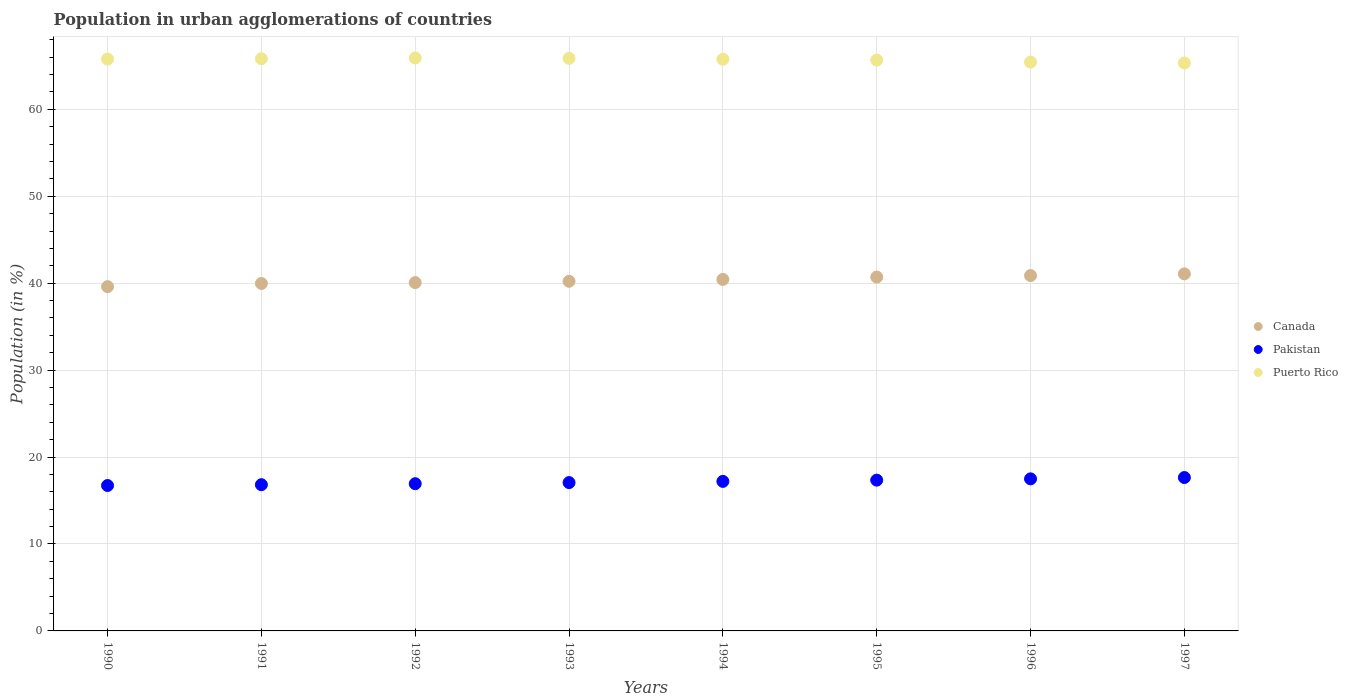What is the percentage of population in urban agglomerations in Puerto Rico in 1993?
Your answer should be very brief. 65.87. Across all years, what is the maximum percentage of population in urban agglomerations in Canada?
Your response must be concise. 41.07. Across all years, what is the minimum percentage of population in urban agglomerations in Puerto Rico?
Your response must be concise. 65.33. What is the total percentage of population in urban agglomerations in Puerto Rico in the graph?
Give a very brief answer. 525.58. What is the difference between the percentage of population in urban agglomerations in Puerto Rico in 1995 and that in 1997?
Make the answer very short. 0.33. What is the difference between the percentage of population in urban agglomerations in Puerto Rico in 1992 and the percentage of population in urban agglomerations in Pakistan in 1997?
Make the answer very short. 48.27. What is the average percentage of population in urban agglomerations in Puerto Rico per year?
Provide a succinct answer. 65.7. In the year 1990, what is the difference between the percentage of population in urban agglomerations in Canada and percentage of population in urban agglomerations in Puerto Rico?
Offer a very short reply. -26.18. In how many years, is the percentage of population in urban agglomerations in Puerto Rico greater than 50 %?
Ensure brevity in your answer.  8. What is the ratio of the percentage of population in urban agglomerations in Canada in 1990 to that in 1997?
Give a very brief answer. 0.96. Is the percentage of population in urban agglomerations in Canada in 1992 less than that in 1993?
Offer a terse response. Yes. Is the difference between the percentage of population in urban agglomerations in Canada in 1991 and 1997 greater than the difference between the percentage of population in urban agglomerations in Puerto Rico in 1991 and 1997?
Keep it short and to the point. No. What is the difference between the highest and the second highest percentage of population in urban agglomerations in Puerto Rico?
Your response must be concise. 0.05. What is the difference between the highest and the lowest percentage of population in urban agglomerations in Pakistan?
Your answer should be compact. 0.92. Is it the case that in every year, the sum of the percentage of population in urban agglomerations in Pakistan and percentage of population in urban agglomerations in Puerto Rico  is greater than the percentage of population in urban agglomerations in Canada?
Your answer should be very brief. Yes. Is the percentage of population in urban agglomerations in Pakistan strictly less than the percentage of population in urban agglomerations in Puerto Rico over the years?
Your answer should be very brief. Yes. How many years are there in the graph?
Make the answer very short. 8. What is the difference between two consecutive major ticks on the Y-axis?
Your response must be concise. 10. Are the values on the major ticks of Y-axis written in scientific E-notation?
Keep it short and to the point. No. Does the graph contain any zero values?
Your response must be concise. No. Does the graph contain grids?
Your answer should be compact. Yes. How many legend labels are there?
Your response must be concise. 3. What is the title of the graph?
Your answer should be very brief. Population in urban agglomerations of countries. What is the Population (in %) in Canada in 1990?
Your answer should be compact. 39.6. What is the Population (in %) of Pakistan in 1990?
Provide a short and direct response. 16.73. What is the Population (in %) in Puerto Rico in 1990?
Offer a terse response. 65.78. What is the Population (in %) in Canada in 1991?
Your response must be concise. 39.97. What is the Population (in %) in Pakistan in 1991?
Your answer should be compact. 16.82. What is the Population (in %) of Puerto Rico in 1991?
Provide a succinct answer. 65.83. What is the Population (in %) in Canada in 1992?
Your answer should be very brief. 40.07. What is the Population (in %) in Pakistan in 1992?
Give a very brief answer. 16.94. What is the Population (in %) of Puerto Rico in 1992?
Provide a short and direct response. 65.91. What is the Population (in %) of Canada in 1993?
Your answer should be very brief. 40.22. What is the Population (in %) in Pakistan in 1993?
Make the answer very short. 17.06. What is the Population (in %) of Puerto Rico in 1993?
Offer a very short reply. 65.87. What is the Population (in %) in Canada in 1994?
Your answer should be compact. 40.44. What is the Population (in %) in Pakistan in 1994?
Offer a terse response. 17.2. What is the Population (in %) in Puerto Rico in 1994?
Your response must be concise. 65.76. What is the Population (in %) of Canada in 1995?
Offer a terse response. 40.7. What is the Population (in %) in Pakistan in 1995?
Give a very brief answer. 17.35. What is the Population (in %) of Puerto Rico in 1995?
Your response must be concise. 65.66. What is the Population (in %) of Canada in 1996?
Your answer should be very brief. 40.88. What is the Population (in %) in Pakistan in 1996?
Provide a succinct answer. 17.49. What is the Population (in %) of Puerto Rico in 1996?
Ensure brevity in your answer.  65.44. What is the Population (in %) in Canada in 1997?
Provide a short and direct response. 41.07. What is the Population (in %) in Pakistan in 1997?
Offer a very short reply. 17.64. What is the Population (in %) in Puerto Rico in 1997?
Provide a short and direct response. 65.33. Across all years, what is the maximum Population (in %) of Canada?
Provide a succinct answer. 41.07. Across all years, what is the maximum Population (in %) in Pakistan?
Offer a very short reply. 17.64. Across all years, what is the maximum Population (in %) of Puerto Rico?
Make the answer very short. 65.91. Across all years, what is the minimum Population (in %) in Canada?
Make the answer very short. 39.6. Across all years, what is the minimum Population (in %) of Pakistan?
Make the answer very short. 16.73. Across all years, what is the minimum Population (in %) in Puerto Rico?
Keep it short and to the point. 65.33. What is the total Population (in %) of Canada in the graph?
Ensure brevity in your answer.  322.95. What is the total Population (in %) in Pakistan in the graph?
Keep it short and to the point. 137.23. What is the total Population (in %) in Puerto Rico in the graph?
Provide a short and direct response. 525.58. What is the difference between the Population (in %) in Canada in 1990 and that in 1991?
Provide a short and direct response. -0.37. What is the difference between the Population (in %) of Pakistan in 1990 and that in 1991?
Provide a succinct answer. -0.09. What is the difference between the Population (in %) in Puerto Rico in 1990 and that in 1991?
Offer a very short reply. -0.04. What is the difference between the Population (in %) of Canada in 1990 and that in 1992?
Your response must be concise. -0.47. What is the difference between the Population (in %) of Pakistan in 1990 and that in 1992?
Provide a succinct answer. -0.21. What is the difference between the Population (in %) in Puerto Rico in 1990 and that in 1992?
Ensure brevity in your answer.  -0.13. What is the difference between the Population (in %) in Canada in 1990 and that in 1993?
Provide a short and direct response. -0.62. What is the difference between the Population (in %) in Pakistan in 1990 and that in 1993?
Your response must be concise. -0.34. What is the difference between the Population (in %) in Puerto Rico in 1990 and that in 1993?
Keep it short and to the point. -0.08. What is the difference between the Population (in %) in Canada in 1990 and that in 1994?
Offer a very short reply. -0.83. What is the difference between the Population (in %) of Pakistan in 1990 and that in 1994?
Your response must be concise. -0.47. What is the difference between the Population (in %) in Puerto Rico in 1990 and that in 1994?
Offer a very short reply. 0.02. What is the difference between the Population (in %) of Canada in 1990 and that in 1995?
Your answer should be compact. -1.1. What is the difference between the Population (in %) in Pakistan in 1990 and that in 1995?
Your answer should be compact. -0.62. What is the difference between the Population (in %) of Puerto Rico in 1990 and that in 1995?
Your answer should be compact. 0.12. What is the difference between the Population (in %) of Canada in 1990 and that in 1996?
Keep it short and to the point. -1.28. What is the difference between the Population (in %) of Pakistan in 1990 and that in 1996?
Make the answer very short. -0.77. What is the difference between the Population (in %) in Puerto Rico in 1990 and that in 1996?
Provide a short and direct response. 0.35. What is the difference between the Population (in %) in Canada in 1990 and that in 1997?
Your response must be concise. -1.47. What is the difference between the Population (in %) of Pakistan in 1990 and that in 1997?
Your answer should be very brief. -0.92. What is the difference between the Population (in %) of Puerto Rico in 1990 and that in 1997?
Provide a short and direct response. 0.45. What is the difference between the Population (in %) of Canada in 1991 and that in 1992?
Your answer should be very brief. -0.1. What is the difference between the Population (in %) in Pakistan in 1991 and that in 1992?
Your response must be concise. -0.11. What is the difference between the Population (in %) in Puerto Rico in 1991 and that in 1992?
Offer a terse response. -0.08. What is the difference between the Population (in %) of Canada in 1991 and that in 1993?
Provide a succinct answer. -0.26. What is the difference between the Population (in %) of Pakistan in 1991 and that in 1993?
Your answer should be very brief. -0.24. What is the difference between the Population (in %) in Puerto Rico in 1991 and that in 1993?
Offer a very short reply. -0.04. What is the difference between the Population (in %) in Canada in 1991 and that in 1994?
Make the answer very short. -0.47. What is the difference between the Population (in %) in Pakistan in 1991 and that in 1994?
Give a very brief answer. -0.38. What is the difference between the Population (in %) in Puerto Rico in 1991 and that in 1994?
Offer a very short reply. 0.06. What is the difference between the Population (in %) in Canada in 1991 and that in 1995?
Your response must be concise. -0.74. What is the difference between the Population (in %) in Pakistan in 1991 and that in 1995?
Provide a short and direct response. -0.52. What is the difference between the Population (in %) of Puerto Rico in 1991 and that in 1995?
Give a very brief answer. 0.16. What is the difference between the Population (in %) in Canada in 1991 and that in 1996?
Offer a terse response. -0.91. What is the difference between the Population (in %) of Pakistan in 1991 and that in 1996?
Provide a short and direct response. -0.67. What is the difference between the Population (in %) of Puerto Rico in 1991 and that in 1996?
Your response must be concise. 0.39. What is the difference between the Population (in %) in Canada in 1991 and that in 1997?
Make the answer very short. -1.11. What is the difference between the Population (in %) in Pakistan in 1991 and that in 1997?
Ensure brevity in your answer.  -0.82. What is the difference between the Population (in %) of Puerto Rico in 1991 and that in 1997?
Offer a terse response. 0.49. What is the difference between the Population (in %) of Canada in 1992 and that in 1993?
Your answer should be very brief. -0.15. What is the difference between the Population (in %) in Pakistan in 1992 and that in 1993?
Offer a terse response. -0.13. What is the difference between the Population (in %) of Puerto Rico in 1992 and that in 1993?
Ensure brevity in your answer.  0.05. What is the difference between the Population (in %) of Canada in 1992 and that in 1994?
Ensure brevity in your answer.  -0.37. What is the difference between the Population (in %) in Pakistan in 1992 and that in 1994?
Your response must be concise. -0.27. What is the difference between the Population (in %) of Puerto Rico in 1992 and that in 1994?
Ensure brevity in your answer.  0.15. What is the difference between the Population (in %) in Canada in 1992 and that in 1995?
Provide a succinct answer. -0.64. What is the difference between the Population (in %) of Pakistan in 1992 and that in 1995?
Give a very brief answer. -0.41. What is the difference between the Population (in %) of Puerto Rico in 1992 and that in 1995?
Your answer should be very brief. 0.25. What is the difference between the Population (in %) in Canada in 1992 and that in 1996?
Give a very brief answer. -0.81. What is the difference between the Population (in %) in Pakistan in 1992 and that in 1996?
Keep it short and to the point. -0.56. What is the difference between the Population (in %) of Puerto Rico in 1992 and that in 1996?
Make the answer very short. 0.48. What is the difference between the Population (in %) of Canada in 1992 and that in 1997?
Your answer should be very brief. -1.01. What is the difference between the Population (in %) in Pakistan in 1992 and that in 1997?
Your response must be concise. -0.71. What is the difference between the Population (in %) of Puerto Rico in 1992 and that in 1997?
Make the answer very short. 0.58. What is the difference between the Population (in %) of Canada in 1993 and that in 1994?
Give a very brief answer. -0.21. What is the difference between the Population (in %) of Pakistan in 1993 and that in 1994?
Your answer should be very brief. -0.14. What is the difference between the Population (in %) in Puerto Rico in 1993 and that in 1994?
Ensure brevity in your answer.  0.1. What is the difference between the Population (in %) of Canada in 1993 and that in 1995?
Give a very brief answer. -0.48. What is the difference between the Population (in %) of Pakistan in 1993 and that in 1995?
Your answer should be very brief. -0.28. What is the difference between the Population (in %) of Puerto Rico in 1993 and that in 1995?
Ensure brevity in your answer.  0.2. What is the difference between the Population (in %) of Canada in 1993 and that in 1996?
Give a very brief answer. -0.65. What is the difference between the Population (in %) in Pakistan in 1993 and that in 1996?
Make the answer very short. -0.43. What is the difference between the Population (in %) in Puerto Rico in 1993 and that in 1996?
Offer a terse response. 0.43. What is the difference between the Population (in %) of Canada in 1993 and that in 1997?
Your response must be concise. -0.85. What is the difference between the Population (in %) of Pakistan in 1993 and that in 1997?
Offer a very short reply. -0.58. What is the difference between the Population (in %) in Puerto Rico in 1993 and that in 1997?
Your answer should be compact. 0.53. What is the difference between the Population (in %) of Canada in 1994 and that in 1995?
Give a very brief answer. -0.27. What is the difference between the Population (in %) of Pakistan in 1994 and that in 1995?
Offer a terse response. -0.14. What is the difference between the Population (in %) of Puerto Rico in 1994 and that in 1995?
Offer a terse response. 0.1. What is the difference between the Population (in %) in Canada in 1994 and that in 1996?
Make the answer very short. -0.44. What is the difference between the Population (in %) in Pakistan in 1994 and that in 1996?
Give a very brief answer. -0.29. What is the difference between the Population (in %) in Puerto Rico in 1994 and that in 1996?
Provide a short and direct response. 0.33. What is the difference between the Population (in %) in Canada in 1994 and that in 1997?
Your answer should be compact. -0.64. What is the difference between the Population (in %) of Pakistan in 1994 and that in 1997?
Offer a terse response. -0.44. What is the difference between the Population (in %) in Puerto Rico in 1994 and that in 1997?
Provide a succinct answer. 0.43. What is the difference between the Population (in %) in Canada in 1995 and that in 1996?
Your response must be concise. -0.17. What is the difference between the Population (in %) in Pakistan in 1995 and that in 1996?
Your answer should be very brief. -0.15. What is the difference between the Population (in %) in Puerto Rico in 1995 and that in 1996?
Offer a very short reply. 0.23. What is the difference between the Population (in %) in Canada in 1995 and that in 1997?
Offer a terse response. -0.37. What is the difference between the Population (in %) of Pakistan in 1995 and that in 1997?
Make the answer very short. -0.3. What is the difference between the Population (in %) in Puerto Rico in 1995 and that in 1997?
Offer a very short reply. 0.33. What is the difference between the Population (in %) in Canada in 1996 and that in 1997?
Offer a very short reply. -0.2. What is the difference between the Population (in %) in Pakistan in 1996 and that in 1997?
Offer a terse response. -0.15. What is the difference between the Population (in %) of Puerto Rico in 1996 and that in 1997?
Your answer should be compact. 0.1. What is the difference between the Population (in %) of Canada in 1990 and the Population (in %) of Pakistan in 1991?
Your answer should be very brief. 22.78. What is the difference between the Population (in %) in Canada in 1990 and the Population (in %) in Puerto Rico in 1991?
Your response must be concise. -26.22. What is the difference between the Population (in %) in Pakistan in 1990 and the Population (in %) in Puerto Rico in 1991?
Your answer should be compact. -49.1. What is the difference between the Population (in %) of Canada in 1990 and the Population (in %) of Pakistan in 1992?
Your answer should be compact. 22.67. What is the difference between the Population (in %) of Canada in 1990 and the Population (in %) of Puerto Rico in 1992?
Offer a very short reply. -26.31. What is the difference between the Population (in %) of Pakistan in 1990 and the Population (in %) of Puerto Rico in 1992?
Give a very brief answer. -49.18. What is the difference between the Population (in %) of Canada in 1990 and the Population (in %) of Pakistan in 1993?
Make the answer very short. 22.54. What is the difference between the Population (in %) of Canada in 1990 and the Population (in %) of Puerto Rico in 1993?
Keep it short and to the point. -26.26. What is the difference between the Population (in %) of Pakistan in 1990 and the Population (in %) of Puerto Rico in 1993?
Keep it short and to the point. -49.14. What is the difference between the Population (in %) of Canada in 1990 and the Population (in %) of Pakistan in 1994?
Make the answer very short. 22.4. What is the difference between the Population (in %) in Canada in 1990 and the Population (in %) in Puerto Rico in 1994?
Keep it short and to the point. -26.16. What is the difference between the Population (in %) of Pakistan in 1990 and the Population (in %) of Puerto Rico in 1994?
Your response must be concise. -49.04. What is the difference between the Population (in %) of Canada in 1990 and the Population (in %) of Pakistan in 1995?
Ensure brevity in your answer.  22.26. What is the difference between the Population (in %) in Canada in 1990 and the Population (in %) in Puerto Rico in 1995?
Give a very brief answer. -26.06. What is the difference between the Population (in %) in Pakistan in 1990 and the Population (in %) in Puerto Rico in 1995?
Your response must be concise. -48.94. What is the difference between the Population (in %) of Canada in 1990 and the Population (in %) of Pakistan in 1996?
Your answer should be compact. 22.11. What is the difference between the Population (in %) in Canada in 1990 and the Population (in %) in Puerto Rico in 1996?
Your answer should be compact. -25.83. What is the difference between the Population (in %) of Pakistan in 1990 and the Population (in %) of Puerto Rico in 1996?
Your answer should be compact. -48.71. What is the difference between the Population (in %) in Canada in 1990 and the Population (in %) in Pakistan in 1997?
Offer a terse response. 21.96. What is the difference between the Population (in %) in Canada in 1990 and the Population (in %) in Puerto Rico in 1997?
Provide a succinct answer. -25.73. What is the difference between the Population (in %) of Pakistan in 1990 and the Population (in %) of Puerto Rico in 1997?
Your answer should be very brief. -48.61. What is the difference between the Population (in %) in Canada in 1991 and the Population (in %) in Pakistan in 1992?
Keep it short and to the point. 23.03. What is the difference between the Population (in %) of Canada in 1991 and the Population (in %) of Puerto Rico in 1992?
Make the answer very short. -25.94. What is the difference between the Population (in %) of Pakistan in 1991 and the Population (in %) of Puerto Rico in 1992?
Your answer should be compact. -49.09. What is the difference between the Population (in %) in Canada in 1991 and the Population (in %) in Pakistan in 1993?
Your response must be concise. 22.91. What is the difference between the Population (in %) in Canada in 1991 and the Population (in %) in Puerto Rico in 1993?
Your answer should be very brief. -25.9. What is the difference between the Population (in %) in Pakistan in 1991 and the Population (in %) in Puerto Rico in 1993?
Offer a very short reply. -49.04. What is the difference between the Population (in %) of Canada in 1991 and the Population (in %) of Pakistan in 1994?
Provide a succinct answer. 22.77. What is the difference between the Population (in %) in Canada in 1991 and the Population (in %) in Puerto Rico in 1994?
Provide a short and direct response. -25.79. What is the difference between the Population (in %) of Pakistan in 1991 and the Population (in %) of Puerto Rico in 1994?
Your answer should be compact. -48.94. What is the difference between the Population (in %) of Canada in 1991 and the Population (in %) of Pakistan in 1995?
Keep it short and to the point. 22.62. What is the difference between the Population (in %) of Canada in 1991 and the Population (in %) of Puerto Rico in 1995?
Provide a short and direct response. -25.7. What is the difference between the Population (in %) in Pakistan in 1991 and the Population (in %) in Puerto Rico in 1995?
Keep it short and to the point. -48.84. What is the difference between the Population (in %) of Canada in 1991 and the Population (in %) of Pakistan in 1996?
Provide a short and direct response. 22.48. What is the difference between the Population (in %) in Canada in 1991 and the Population (in %) in Puerto Rico in 1996?
Give a very brief answer. -25.47. What is the difference between the Population (in %) of Pakistan in 1991 and the Population (in %) of Puerto Rico in 1996?
Provide a short and direct response. -48.62. What is the difference between the Population (in %) of Canada in 1991 and the Population (in %) of Pakistan in 1997?
Your answer should be very brief. 22.32. What is the difference between the Population (in %) in Canada in 1991 and the Population (in %) in Puerto Rico in 1997?
Offer a terse response. -25.37. What is the difference between the Population (in %) in Pakistan in 1991 and the Population (in %) in Puerto Rico in 1997?
Provide a short and direct response. -48.51. What is the difference between the Population (in %) in Canada in 1992 and the Population (in %) in Pakistan in 1993?
Provide a short and direct response. 23.01. What is the difference between the Population (in %) of Canada in 1992 and the Population (in %) of Puerto Rico in 1993?
Offer a terse response. -25.8. What is the difference between the Population (in %) in Pakistan in 1992 and the Population (in %) in Puerto Rico in 1993?
Keep it short and to the point. -48.93. What is the difference between the Population (in %) in Canada in 1992 and the Population (in %) in Pakistan in 1994?
Make the answer very short. 22.87. What is the difference between the Population (in %) of Canada in 1992 and the Population (in %) of Puerto Rico in 1994?
Make the answer very short. -25.69. What is the difference between the Population (in %) in Pakistan in 1992 and the Population (in %) in Puerto Rico in 1994?
Give a very brief answer. -48.83. What is the difference between the Population (in %) of Canada in 1992 and the Population (in %) of Pakistan in 1995?
Give a very brief answer. 22.72. What is the difference between the Population (in %) of Canada in 1992 and the Population (in %) of Puerto Rico in 1995?
Make the answer very short. -25.6. What is the difference between the Population (in %) of Pakistan in 1992 and the Population (in %) of Puerto Rico in 1995?
Keep it short and to the point. -48.73. What is the difference between the Population (in %) in Canada in 1992 and the Population (in %) in Pakistan in 1996?
Give a very brief answer. 22.58. What is the difference between the Population (in %) of Canada in 1992 and the Population (in %) of Puerto Rico in 1996?
Provide a succinct answer. -25.37. What is the difference between the Population (in %) in Pakistan in 1992 and the Population (in %) in Puerto Rico in 1996?
Make the answer very short. -48.5. What is the difference between the Population (in %) of Canada in 1992 and the Population (in %) of Pakistan in 1997?
Your response must be concise. 22.42. What is the difference between the Population (in %) in Canada in 1992 and the Population (in %) in Puerto Rico in 1997?
Provide a short and direct response. -25.26. What is the difference between the Population (in %) of Pakistan in 1992 and the Population (in %) of Puerto Rico in 1997?
Ensure brevity in your answer.  -48.4. What is the difference between the Population (in %) of Canada in 1993 and the Population (in %) of Pakistan in 1994?
Your answer should be compact. 23.02. What is the difference between the Population (in %) in Canada in 1993 and the Population (in %) in Puerto Rico in 1994?
Keep it short and to the point. -25.54. What is the difference between the Population (in %) of Pakistan in 1993 and the Population (in %) of Puerto Rico in 1994?
Ensure brevity in your answer.  -48.7. What is the difference between the Population (in %) in Canada in 1993 and the Population (in %) in Pakistan in 1995?
Your response must be concise. 22.88. What is the difference between the Population (in %) in Canada in 1993 and the Population (in %) in Puerto Rico in 1995?
Your answer should be compact. -25.44. What is the difference between the Population (in %) in Pakistan in 1993 and the Population (in %) in Puerto Rico in 1995?
Give a very brief answer. -48.6. What is the difference between the Population (in %) of Canada in 1993 and the Population (in %) of Pakistan in 1996?
Your answer should be very brief. 22.73. What is the difference between the Population (in %) in Canada in 1993 and the Population (in %) in Puerto Rico in 1996?
Give a very brief answer. -25.21. What is the difference between the Population (in %) of Pakistan in 1993 and the Population (in %) of Puerto Rico in 1996?
Make the answer very short. -48.37. What is the difference between the Population (in %) of Canada in 1993 and the Population (in %) of Pakistan in 1997?
Ensure brevity in your answer.  22.58. What is the difference between the Population (in %) of Canada in 1993 and the Population (in %) of Puerto Rico in 1997?
Offer a very short reply. -25.11. What is the difference between the Population (in %) of Pakistan in 1993 and the Population (in %) of Puerto Rico in 1997?
Provide a succinct answer. -48.27. What is the difference between the Population (in %) in Canada in 1994 and the Population (in %) in Pakistan in 1995?
Offer a terse response. 23.09. What is the difference between the Population (in %) in Canada in 1994 and the Population (in %) in Puerto Rico in 1995?
Your answer should be compact. -25.23. What is the difference between the Population (in %) in Pakistan in 1994 and the Population (in %) in Puerto Rico in 1995?
Your answer should be compact. -48.46. What is the difference between the Population (in %) of Canada in 1994 and the Population (in %) of Pakistan in 1996?
Make the answer very short. 22.94. What is the difference between the Population (in %) in Canada in 1994 and the Population (in %) in Puerto Rico in 1996?
Your response must be concise. -25. What is the difference between the Population (in %) of Pakistan in 1994 and the Population (in %) of Puerto Rico in 1996?
Your answer should be compact. -48.23. What is the difference between the Population (in %) of Canada in 1994 and the Population (in %) of Pakistan in 1997?
Provide a short and direct response. 22.79. What is the difference between the Population (in %) in Canada in 1994 and the Population (in %) in Puerto Rico in 1997?
Your answer should be compact. -24.9. What is the difference between the Population (in %) of Pakistan in 1994 and the Population (in %) of Puerto Rico in 1997?
Your response must be concise. -48.13. What is the difference between the Population (in %) of Canada in 1995 and the Population (in %) of Pakistan in 1996?
Your answer should be compact. 23.21. What is the difference between the Population (in %) in Canada in 1995 and the Population (in %) in Puerto Rico in 1996?
Your answer should be compact. -24.73. What is the difference between the Population (in %) of Pakistan in 1995 and the Population (in %) of Puerto Rico in 1996?
Provide a succinct answer. -48.09. What is the difference between the Population (in %) of Canada in 1995 and the Population (in %) of Pakistan in 1997?
Your response must be concise. 23.06. What is the difference between the Population (in %) in Canada in 1995 and the Population (in %) in Puerto Rico in 1997?
Offer a terse response. -24.63. What is the difference between the Population (in %) in Pakistan in 1995 and the Population (in %) in Puerto Rico in 1997?
Provide a short and direct response. -47.99. What is the difference between the Population (in %) of Canada in 1996 and the Population (in %) of Pakistan in 1997?
Your answer should be very brief. 23.23. What is the difference between the Population (in %) in Canada in 1996 and the Population (in %) in Puerto Rico in 1997?
Offer a very short reply. -24.46. What is the difference between the Population (in %) of Pakistan in 1996 and the Population (in %) of Puerto Rico in 1997?
Ensure brevity in your answer.  -47.84. What is the average Population (in %) in Canada per year?
Ensure brevity in your answer.  40.37. What is the average Population (in %) in Pakistan per year?
Ensure brevity in your answer.  17.15. What is the average Population (in %) in Puerto Rico per year?
Keep it short and to the point. 65.7. In the year 1990, what is the difference between the Population (in %) of Canada and Population (in %) of Pakistan?
Offer a very short reply. 22.88. In the year 1990, what is the difference between the Population (in %) in Canada and Population (in %) in Puerto Rico?
Offer a very short reply. -26.18. In the year 1990, what is the difference between the Population (in %) of Pakistan and Population (in %) of Puerto Rico?
Offer a terse response. -49.06. In the year 1991, what is the difference between the Population (in %) in Canada and Population (in %) in Pakistan?
Provide a succinct answer. 23.15. In the year 1991, what is the difference between the Population (in %) of Canada and Population (in %) of Puerto Rico?
Your response must be concise. -25.86. In the year 1991, what is the difference between the Population (in %) in Pakistan and Population (in %) in Puerto Rico?
Offer a very short reply. -49.01. In the year 1992, what is the difference between the Population (in %) of Canada and Population (in %) of Pakistan?
Make the answer very short. 23.13. In the year 1992, what is the difference between the Population (in %) in Canada and Population (in %) in Puerto Rico?
Your response must be concise. -25.84. In the year 1992, what is the difference between the Population (in %) of Pakistan and Population (in %) of Puerto Rico?
Your answer should be very brief. -48.98. In the year 1993, what is the difference between the Population (in %) of Canada and Population (in %) of Pakistan?
Keep it short and to the point. 23.16. In the year 1993, what is the difference between the Population (in %) of Canada and Population (in %) of Puerto Rico?
Make the answer very short. -25.64. In the year 1993, what is the difference between the Population (in %) in Pakistan and Population (in %) in Puerto Rico?
Offer a very short reply. -48.8. In the year 1994, what is the difference between the Population (in %) of Canada and Population (in %) of Pakistan?
Give a very brief answer. 23.23. In the year 1994, what is the difference between the Population (in %) in Canada and Population (in %) in Puerto Rico?
Keep it short and to the point. -25.33. In the year 1994, what is the difference between the Population (in %) of Pakistan and Population (in %) of Puerto Rico?
Provide a succinct answer. -48.56. In the year 1995, what is the difference between the Population (in %) in Canada and Population (in %) in Pakistan?
Your answer should be compact. 23.36. In the year 1995, what is the difference between the Population (in %) of Canada and Population (in %) of Puerto Rico?
Keep it short and to the point. -24.96. In the year 1995, what is the difference between the Population (in %) in Pakistan and Population (in %) in Puerto Rico?
Your answer should be very brief. -48.32. In the year 1996, what is the difference between the Population (in %) in Canada and Population (in %) in Pakistan?
Offer a terse response. 23.39. In the year 1996, what is the difference between the Population (in %) in Canada and Population (in %) in Puerto Rico?
Your answer should be very brief. -24.56. In the year 1996, what is the difference between the Population (in %) of Pakistan and Population (in %) of Puerto Rico?
Offer a terse response. -47.94. In the year 1997, what is the difference between the Population (in %) in Canada and Population (in %) in Pakistan?
Your answer should be compact. 23.43. In the year 1997, what is the difference between the Population (in %) in Canada and Population (in %) in Puerto Rico?
Your response must be concise. -24.26. In the year 1997, what is the difference between the Population (in %) in Pakistan and Population (in %) in Puerto Rico?
Give a very brief answer. -47.69. What is the ratio of the Population (in %) in Canada in 1990 to that in 1991?
Provide a succinct answer. 0.99. What is the ratio of the Population (in %) of Pakistan in 1990 to that in 1991?
Give a very brief answer. 0.99. What is the ratio of the Population (in %) of Canada in 1990 to that in 1992?
Provide a short and direct response. 0.99. What is the ratio of the Population (in %) in Pakistan in 1990 to that in 1992?
Make the answer very short. 0.99. What is the ratio of the Population (in %) of Canada in 1990 to that in 1993?
Your answer should be very brief. 0.98. What is the ratio of the Population (in %) in Pakistan in 1990 to that in 1993?
Your answer should be very brief. 0.98. What is the ratio of the Population (in %) of Canada in 1990 to that in 1994?
Provide a succinct answer. 0.98. What is the ratio of the Population (in %) of Pakistan in 1990 to that in 1994?
Give a very brief answer. 0.97. What is the ratio of the Population (in %) in Puerto Rico in 1990 to that in 1994?
Give a very brief answer. 1. What is the ratio of the Population (in %) of Canada in 1990 to that in 1995?
Your response must be concise. 0.97. What is the ratio of the Population (in %) of Pakistan in 1990 to that in 1995?
Your response must be concise. 0.96. What is the ratio of the Population (in %) in Puerto Rico in 1990 to that in 1995?
Your response must be concise. 1. What is the ratio of the Population (in %) in Canada in 1990 to that in 1996?
Offer a very short reply. 0.97. What is the ratio of the Population (in %) in Pakistan in 1990 to that in 1996?
Your response must be concise. 0.96. What is the ratio of the Population (in %) of Canada in 1990 to that in 1997?
Provide a succinct answer. 0.96. What is the ratio of the Population (in %) of Pakistan in 1990 to that in 1997?
Ensure brevity in your answer.  0.95. What is the ratio of the Population (in %) in Pakistan in 1991 to that in 1992?
Make the answer very short. 0.99. What is the ratio of the Population (in %) of Puerto Rico in 1991 to that in 1992?
Keep it short and to the point. 1. What is the ratio of the Population (in %) of Pakistan in 1991 to that in 1993?
Offer a very short reply. 0.99. What is the ratio of the Population (in %) of Puerto Rico in 1991 to that in 1993?
Provide a short and direct response. 1. What is the ratio of the Population (in %) of Canada in 1991 to that in 1994?
Provide a succinct answer. 0.99. What is the ratio of the Population (in %) in Pakistan in 1991 to that in 1994?
Your answer should be compact. 0.98. What is the ratio of the Population (in %) of Puerto Rico in 1991 to that in 1994?
Ensure brevity in your answer.  1. What is the ratio of the Population (in %) in Canada in 1991 to that in 1995?
Provide a succinct answer. 0.98. What is the ratio of the Population (in %) in Pakistan in 1991 to that in 1995?
Give a very brief answer. 0.97. What is the ratio of the Population (in %) in Canada in 1991 to that in 1996?
Offer a very short reply. 0.98. What is the ratio of the Population (in %) of Pakistan in 1991 to that in 1996?
Give a very brief answer. 0.96. What is the ratio of the Population (in %) of Puerto Rico in 1991 to that in 1996?
Provide a short and direct response. 1.01. What is the ratio of the Population (in %) in Canada in 1991 to that in 1997?
Provide a succinct answer. 0.97. What is the ratio of the Population (in %) in Pakistan in 1991 to that in 1997?
Provide a short and direct response. 0.95. What is the ratio of the Population (in %) in Puerto Rico in 1991 to that in 1997?
Provide a succinct answer. 1.01. What is the ratio of the Population (in %) of Pakistan in 1992 to that in 1993?
Keep it short and to the point. 0.99. What is the ratio of the Population (in %) in Canada in 1992 to that in 1994?
Provide a succinct answer. 0.99. What is the ratio of the Population (in %) in Pakistan in 1992 to that in 1994?
Your answer should be very brief. 0.98. What is the ratio of the Population (in %) of Canada in 1992 to that in 1995?
Your answer should be compact. 0.98. What is the ratio of the Population (in %) in Pakistan in 1992 to that in 1995?
Your answer should be compact. 0.98. What is the ratio of the Population (in %) of Canada in 1992 to that in 1996?
Offer a very short reply. 0.98. What is the ratio of the Population (in %) of Pakistan in 1992 to that in 1996?
Your answer should be compact. 0.97. What is the ratio of the Population (in %) of Puerto Rico in 1992 to that in 1996?
Keep it short and to the point. 1.01. What is the ratio of the Population (in %) in Canada in 1992 to that in 1997?
Your response must be concise. 0.98. What is the ratio of the Population (in %) of Pakistan in 1992 to that in 1997?
Make the answer very short. 0.96. What is the ratio of the Population (in %) of Puerto Rico in 1992 to that in 1997?
Offer a very short reply. 1.01. What is the ratio of the Population (in %) of Canada in 1993 to that in 1994?
Your answer should be very brief. 0.99. What is the ratio of the Population (in %) of Pakistan in 1993 to that in 1994?
Your answer should be compact. 0.99. What is the ratio of the Population (in %) in Pakistan in 1993 to that in 1995?
Keep it short and to the point. 0.98. What is the ratio of the Population (in %) in Puerto Rico in 1993 to that in 1995?
Offer a terse response. 1. What is the ratio of the Population (in %) of Pakistan in 1993 to that in 1996?
Make the answer very short. 0.98. What is the ratio of the Population (in %) of Puerto Rico in 1993 to that in 1996?
Offer a terse response. 1.01. What is the ratio of the Population (in %) in Canada in 1993 to that in 1997?
Offer a terse response. 0.98. What is the ratio of the Population (in %) of Pakistan in 1993 to that in 1997?
Offer a terse response. 0.97. What is the ratio of the Population (in %) in Puerto Rico in 1993 to that in 1997?
Keep it short and to the point. 1.01. What is the ratio of the Population (in %) in Canada in 1994 to that in 1995?
Your response must be concise. 0.99. What is the ratio of the Population (in %) in Pakistan in 1994 to that in 1995?
Ensure brevity in your answer.  0.99. What is the ratio of the Population (in %) of Pakistan in 1994 to that in 1996?
Your answer should be very brief. 0.98. What is the ratio of the Population (in %) of Puerto Rico in 1994 to that in 1996?
Your answer should be compact. 1. What is the ratio of the Population (in %) of Canada in 1994 to that in 1997?
Your answer should be very brief. 0.98. What is the ratio of the Population (in %) of Pakistan in 1994 to that in 1997?
Give a very brief answer. 0.97. What is the ratio of the Population (in %) of Puerto Rico in 1994 to that in 1997?
Provide a short and direct response. 1.01. What is the ratio of the Population (in %) in Canada in 1995 to that in 1996?
Your response must be concise. 1. What is the ratio of the Population (in %) in Pakistan in 1995 to that in 1996?
Ensure brevity in your answer.  0.99. What is the ratio of the Population (in %) in Puerto Rico in 1995 to that in 1997?
Keep it short and to the point. 1.01. What is the ratio of the Population (in %) in Puerto Rico in 1996 to that in 1997?
Offer a very short reply. 1. What is the difference between the highest and the second highest Population (in %) of Canada?
Provide a succinct answer. 0.2. What is the difference between the highest and the second highest Population (in %) in Pakistan?
Give a very brief answer. 0.15. What is the difference between the highest and the second highest Population (in %) of Puerto Rico?
Your answer should be very brief. 0.05. What is the difference between the highest and the lowest Population (in %) in Canada?
Your answer should be very brief. 1.47. What is the difference between the highest and the lowest Population (in %) of Pakistan?
Offer a very short reply. 0.92. What is the difference between the highest and the lowest Population (in %) of Puerto Rico?
Keep it short and to the point. 0.58. 